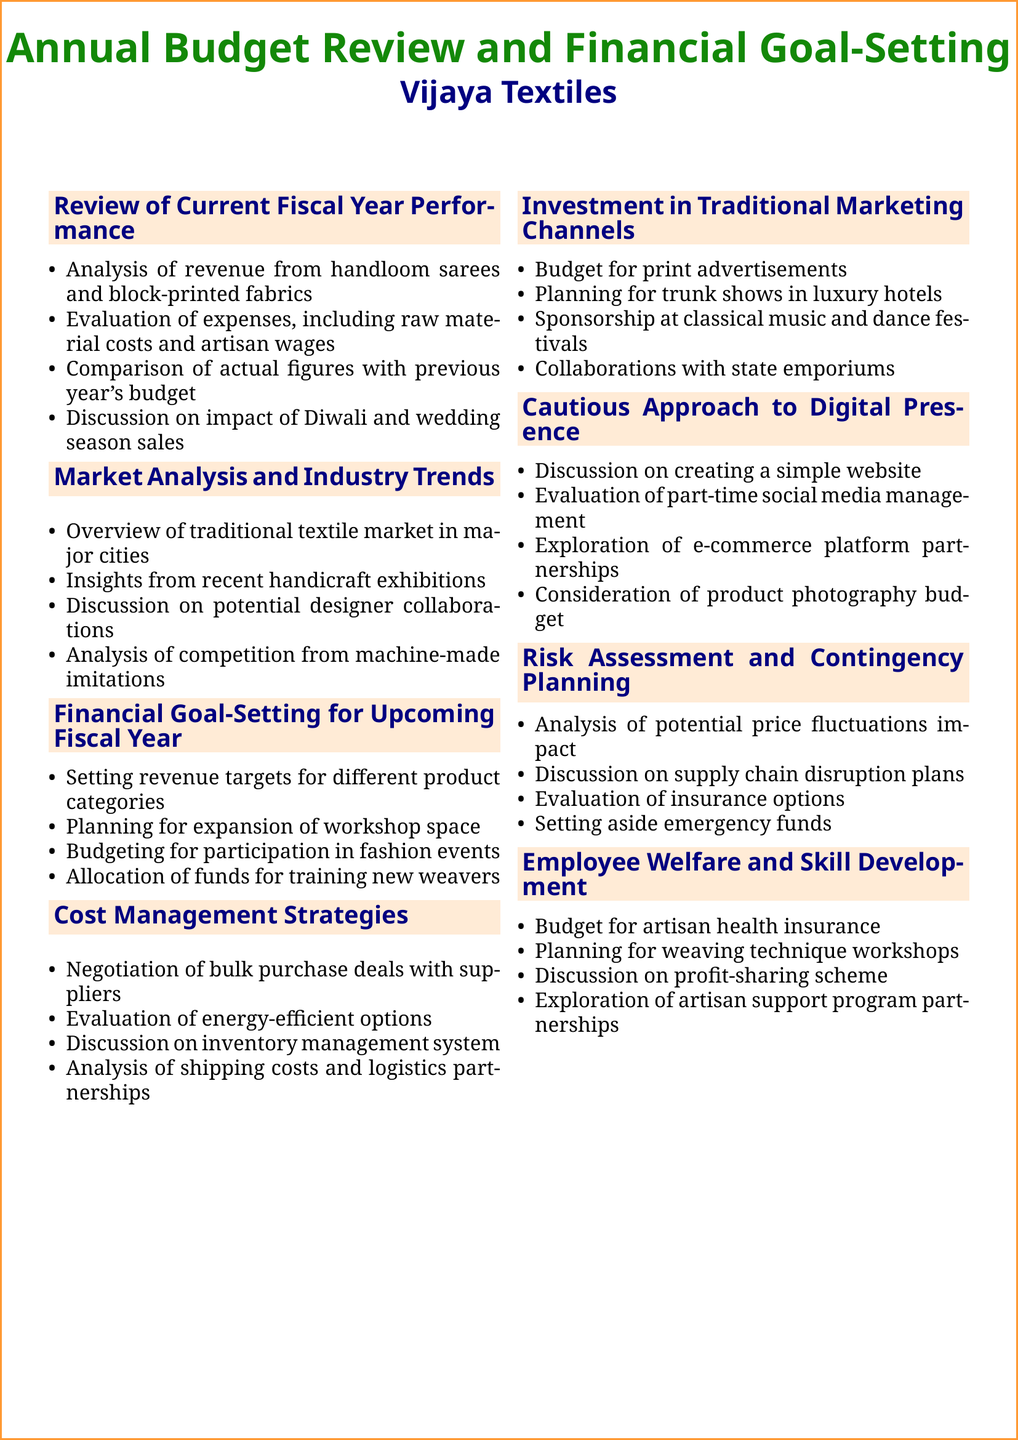What are the key product categories for revenue targets? The document lists Banarasi silk and Chanderi cotton as specific product categories for revenue targets.
Answer: Banarasi silk, Chanderi cotton What season's sales are discussed in relation to performance? The agenda mentions discussing the impact of Diwali and wedding season sales on revenue.
Answer: Diwali, wedding season What marketing channels are being allocated budget for? The document outlines print advertisements in Femina and Vogue India among other traditional marketing channels.
Answer: Print advertisements What is one proposed event for participation in the upcoming fiscal year? The document mentions budgeting for participation in Lakme Fashion Week as an upcoming event.
Answer: Lakme Fashion Week What is one potential strategy for cost management? The agenda discusses the negotiation of bulk purchase deals with silk suppliers in Surat as a cost management strategy.
Answer: Bulk purchase deals How much budget is allocated for artisan health insurance? The document states a budget allocation for health insurance for artisans is in place.
Answer: Health insurance What collaboration opportunity is mentioned in market analysis? The document discusses a potential collaboration with fashion designer Sabyasachi Mukherjee in the market analysis section.
Answer: Sabyasachi Mukherjee What type of website is proposed for digital presence? The agenda suggests creating a simple website to showcase the product catalog as part of the digital presence.
Answer: Simple website What are the emergency funds meant for? The document describes that emergency funds are set aside for unforeseen circumstances as part of risk assessment.
Answer: Unforeseen circumstances 